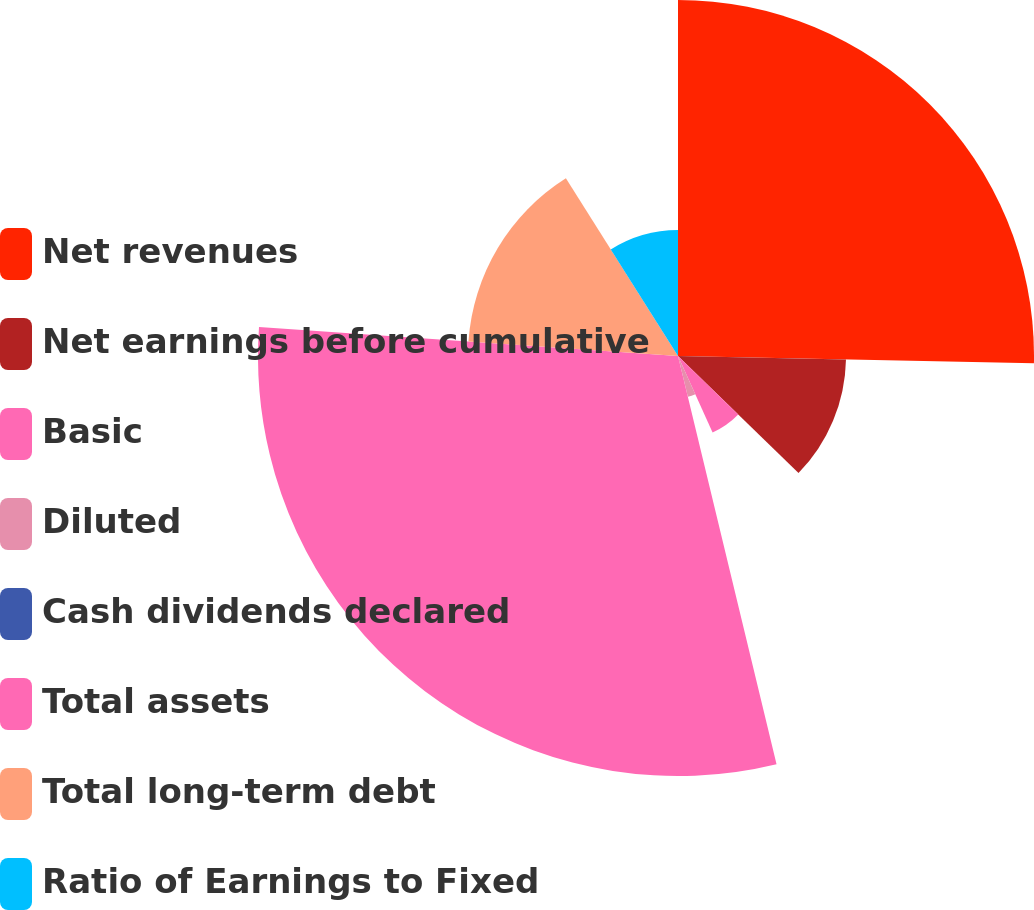<chart> <loc_0><loc_0><loc_500><loc_500><pie_chart><fcel>Net revenues<fcel>Net earnings before cumulative<fcel>Basic<fcel>Diluted<fcel>Cash dividends declared<fcel>Total assets<fcel>Total long-term debt<fcel>Ratio of Earnings to Fixed<nl><fcel>25.32%<fcel>11.95%<fcel>5.97%<fcel>2.99%<fcel>0.0%<fcel>29.87%<fcel>14.94%<fcel>8.96%<nl></chart> 